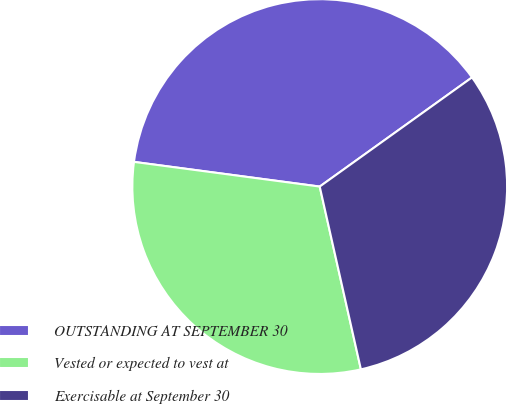<chart> <loc_0><loc_0><loc_500><loc_500><pie_chart><fcel>OUTSTANDING AT SEPTEMBER 30<fcel>Vested or expected to vest at<fcel>Exercisable at September 30<nl><fcel>38.0%<fcel>30.63%<fcel>31.37%<nl></chart> 